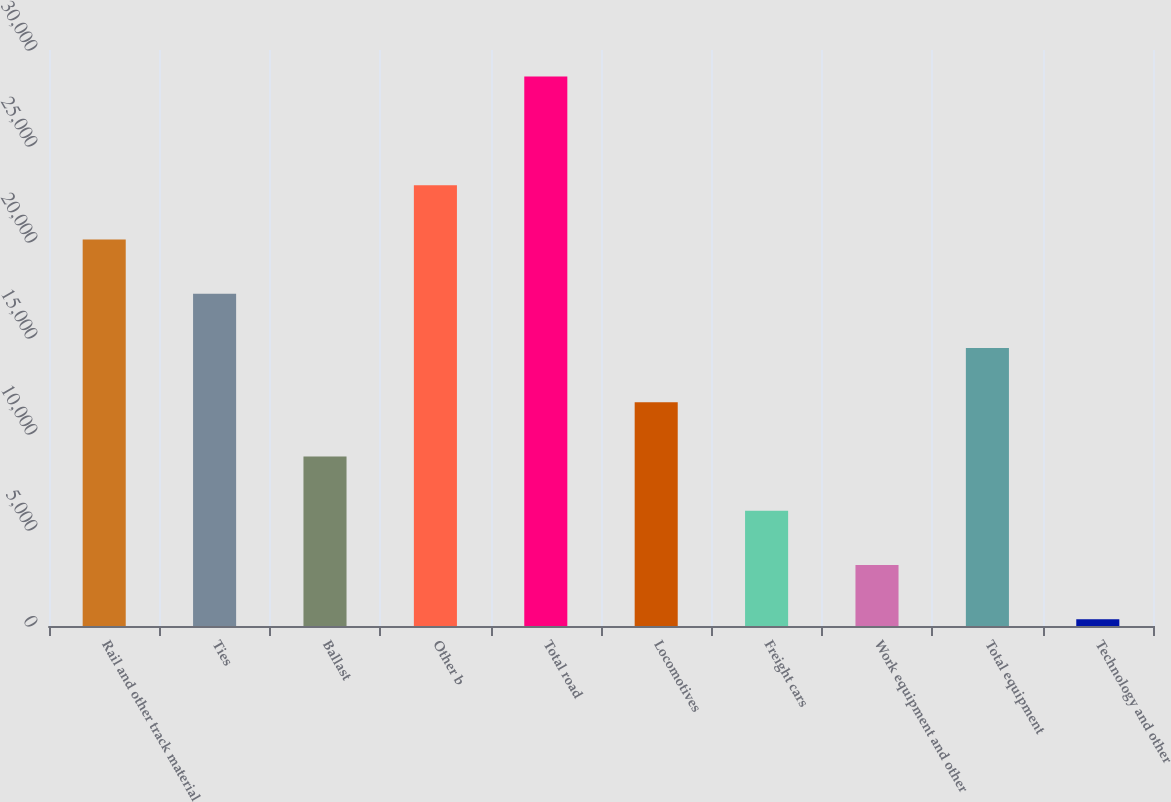Convert chart. <chart><loc_0><loc_0><loc_500><loc_500><bar_chart><fcel>Rail and other track material<fcel>Ties<fcel>Ballast<fcel>Other b<fcel>Total road<fcel>Locomotives<fcel>Freight cars<fcel>Work equipment and other<fcel>Total equipment<fcel>Technology and other<nl><fcel>20135.1<fcel>17308.8<fcel>8829.9<fcel>22961.4<fcel>28614<fcel>11656.2<fcel>6003.6<fcel>3177.3<fcel>14482.5<fcel>351<nl></chart> 